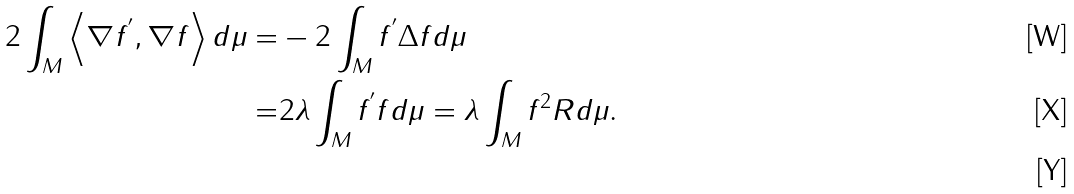Convert formula to latex. <formula><loc_0><loc_0><loc_500><loc_500>2 \int _ { M } \left \langle \nabla f ^ { ^ { \prime } } , \nabla f \right \rangle d \mu = & - 2 \int _ { M } f ^ { ^ { \prime } } \Delta f d \mu \\ = & 2 \lambda \int _ { M } f ^ { ^ { \prime } } f d \mu = \lambda \int _ { M } f ^ { 2 } R d \mu . \\</formula> 